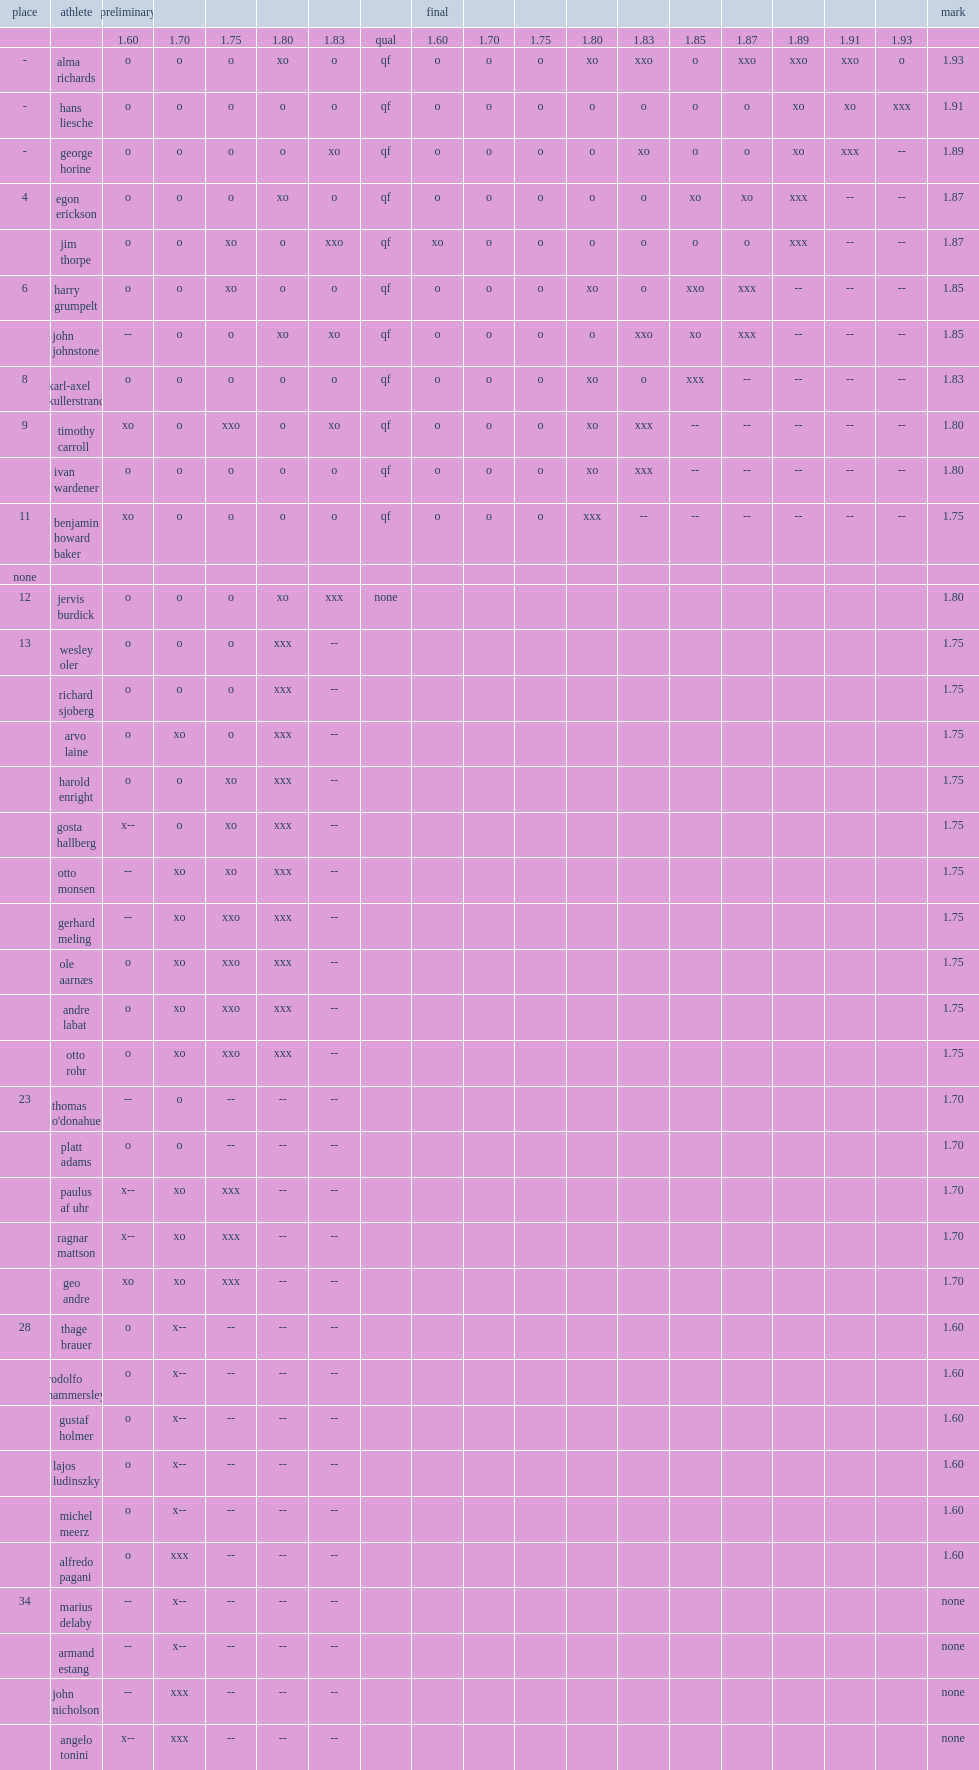How many meters did alma richards set as olympic record with? 1.93. 